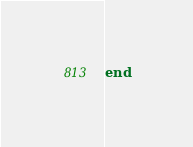<code> <loc_0><loc_0><loc_500><loc_500><_Ruby_>end
</code> 